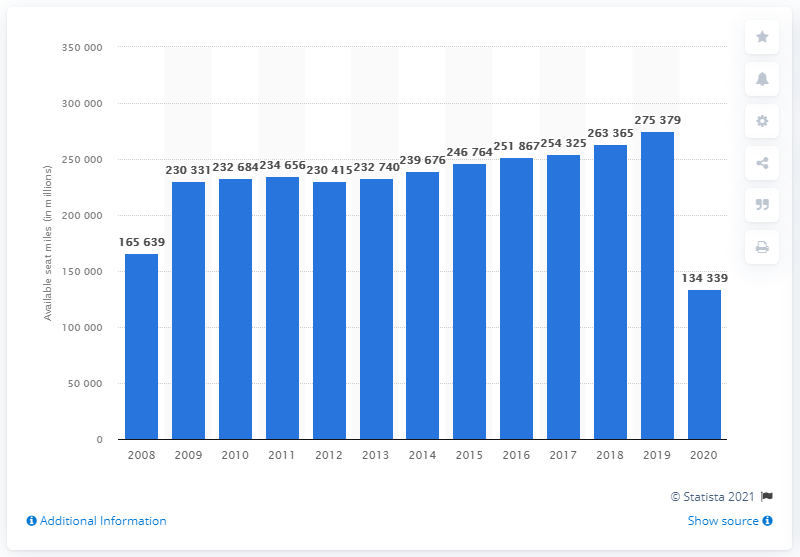Point out several critical features in this image. In 2020, Delta Air Lines had a total of 134,339 available seat miles available for use. 